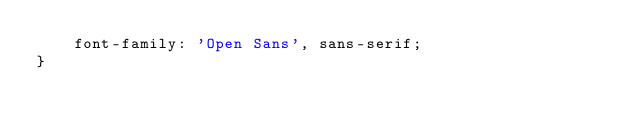<code> <loc_0><loc_0><loc_500><loc_500><_CSS_>    font-family: 'Open Sans', sans-serif;
}

</code> 